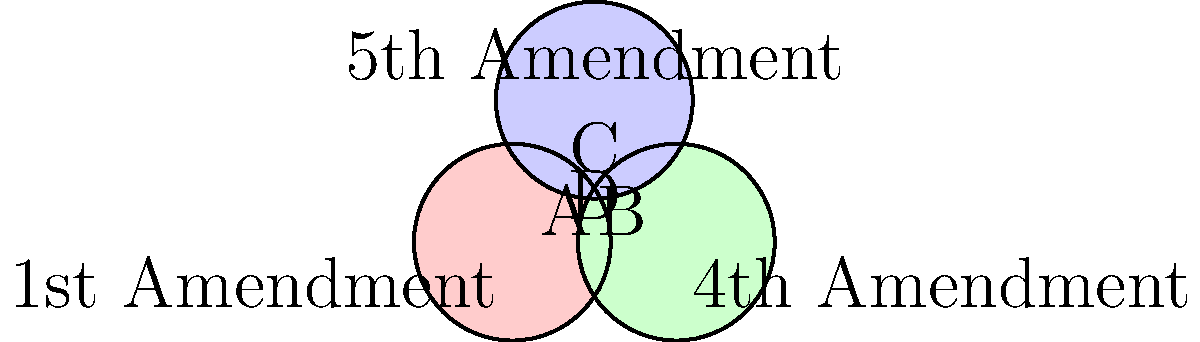In the Venn diagram above, the circles represent the rights protected by the 1st, 4th, and 5th Amendments to the U.S. Constitution. Which region (A, B, C, or D) represents the constitutional rights that are protected by all three amendments simultaneously? To answer this question, we need to analyze the Venn diagram and understand the concept of overlapping sets:

1. The circle on the left represents the rights protected by the 1st Amendment.
2. The circle on the right represents the rights protected by the 4th Amendment.
3. The circle on the top represents the rights protected by the 5th Amendment.
4. Region A represents rights protected only by the 1st Amendment.
5. Region B represents rights protected only by the 4th Amendment.
6. Region C represents rights protected only by the 5th Amendment.
7. The overlapping regions represent rights protected by multiple amendments.
8. Region D, in the center where all three circles overlap, represents the rights that are protected by all three amendments simultaneously.

Therefore, the region that represents the constitutional rights protected by all three amendments (1st, 4th, and 5th) is region D, which is the area where all three circles intersect in the center of the diagram.
Answer: D 